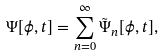<formula> <loc_0><loc_0><loc_500><loc_500>\Psi [ \phi , t ] = \sum _ { n = 0 } ^ { \infty } \tilde { \Psi } _ { n } [ \phi , t ] ,</formula> 